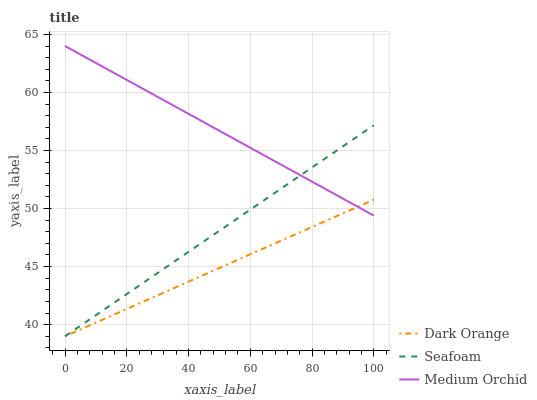Does Dark Orange have the minimum area under the curve?
Answer yes or no. Yes. Does Medium Orchid have the maximum area under the curve?
Answer yes or no. Yes. Does Seafoam have the minimum area under the curve?
Answer yes or no. No. Does Seafoam have the maximum area under the curve?
Answer yes or no. No. Is Dark Orange the smoothest?
Answer yes or no. Yes. Is Medium Orchid the roughest?
Answer yes or no. Yes. Is Seafoam the smoothest?
Answer yes or no. No. Is Seafoam the roughest?
Answer yes or no. No. Does Dark Orange have the lowest value?
Answer yes or no. Yes. Does Medium Orchid have the lowest value?
Answer yes or no. No. Does Medium Orchid have the highest value?
Answer yes or no. Yes. Does Seafoam have the highest value?
Answer yes or no. No. Does Dark Orange intersect Medium Orchid?
Answer yes or no. Yes. Is Dark Orange less than Medium Orchid?
Answer yes or no. No. Is Dark Orange greater than Medium Orchid?
Answer yes or no. No. 